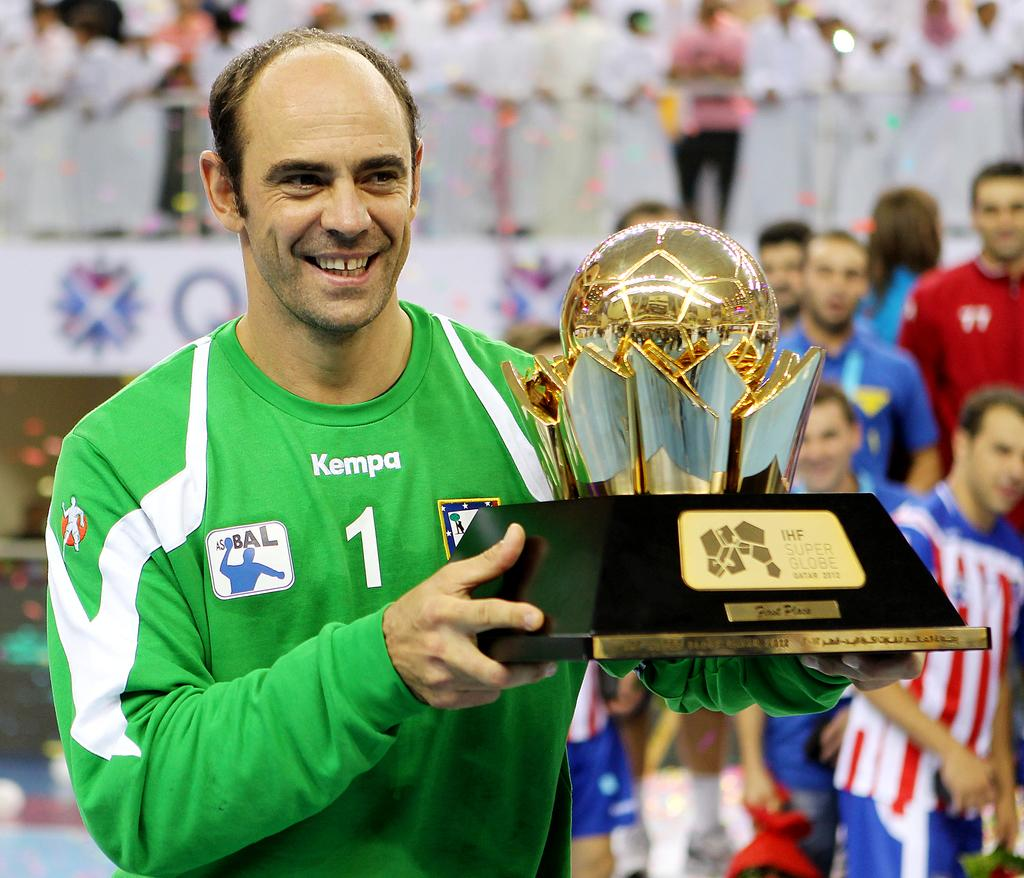What is happening in the image involving the people? There are people standing in the image. Can you describe the man holding a moment in his hand? The man is standing and holding a moment in his hand. What is the man's facial expression? The man has a smile on his face. What color combination is the man wearing on his t-shirt? The man is wearing a green and white color t-shirt. What direction is the pig facing in the image? There is no pig present in the image. How bright is the light shining on the people in the image? There is no light shining on the people in the image; it is not mentioned in the provided facts. 